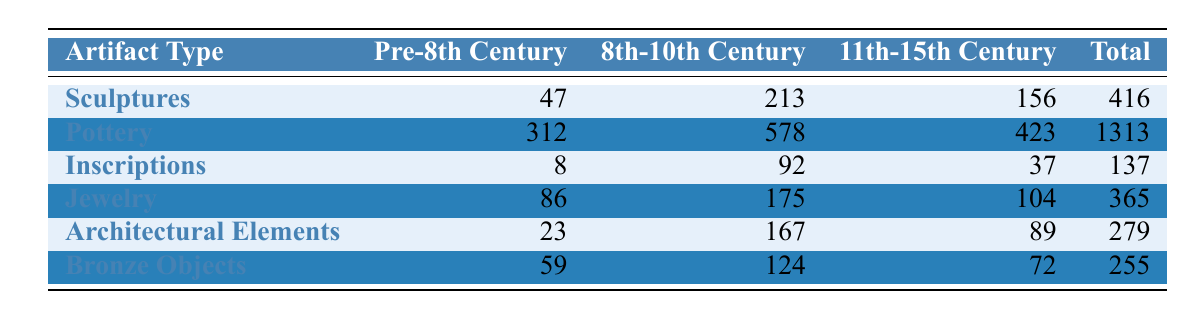What is the total number of sculptures in the inventory? The table indicates that the total number of sculptures is listed in the "Total" column. For sculptures, it shows a total of 416.
Answer: 416 How many pottery artifacts are recorded from the 11th-15th Century? In the table, looking at the "11th-15th Century" column for pottery reveals 423 artifacts.
Answer: 423 What is the combined total of inscriptions and bronze objects? To find the combined total, we sum the totals for inscriptions (137) and bronze objects (255). Thus, 137 + 255 equals 392.
Answer: 392 Is there more jewelry from the 8th-10th Century than from the Pre-8th Century? The jewelry count for the 8th-10th Century is 175, while for the Pre-8th Century, it is 86. Since 175 is greater than 86, the statement is true.
Answer: Yes Which artifact type has the highest total count? By examining the "Total" column, we find that pottery has the highest total at 1313. Other totals like sculptures (416), inscriptions (137), and others are less. Therefore, pottery has the highest count.
Answer: Pottery What is the average number of architectural elements across all periods? To find the average, we take the total number of architectural elements (279) and divide it by the number of periods (3, considering Pre-8th, 8th-10th, and 11th-15th Century). So, 279 divided by 3 equals 93.
Answer: 93 In which period do we see the least number of artifacts for inscriptions? We compare the counts for inscriptions across all periods: Pre-8th Century (8), 8th-10th Century (92), and 11th-15th Century (37). The least count is from the Pre-8th Century with 8 artifacts.
Answer: Pre-8th Century How many total artifacts are there for the 8th-10th Century when combining sculptures and jewelry? We add the counts for sculptures (213) and jewelry (175) from the 8th-10th Century, yielding 213 + 175 = 388.
Answer: 388 Are there more bronze objects than architectural elements in the Pre-8th Century? Comparing the counts: bronze objects (59) and architectural elements (23) in the Pre-8th Century, 59 is greater than 23, confirming the statement as true.
Answer: Yes 